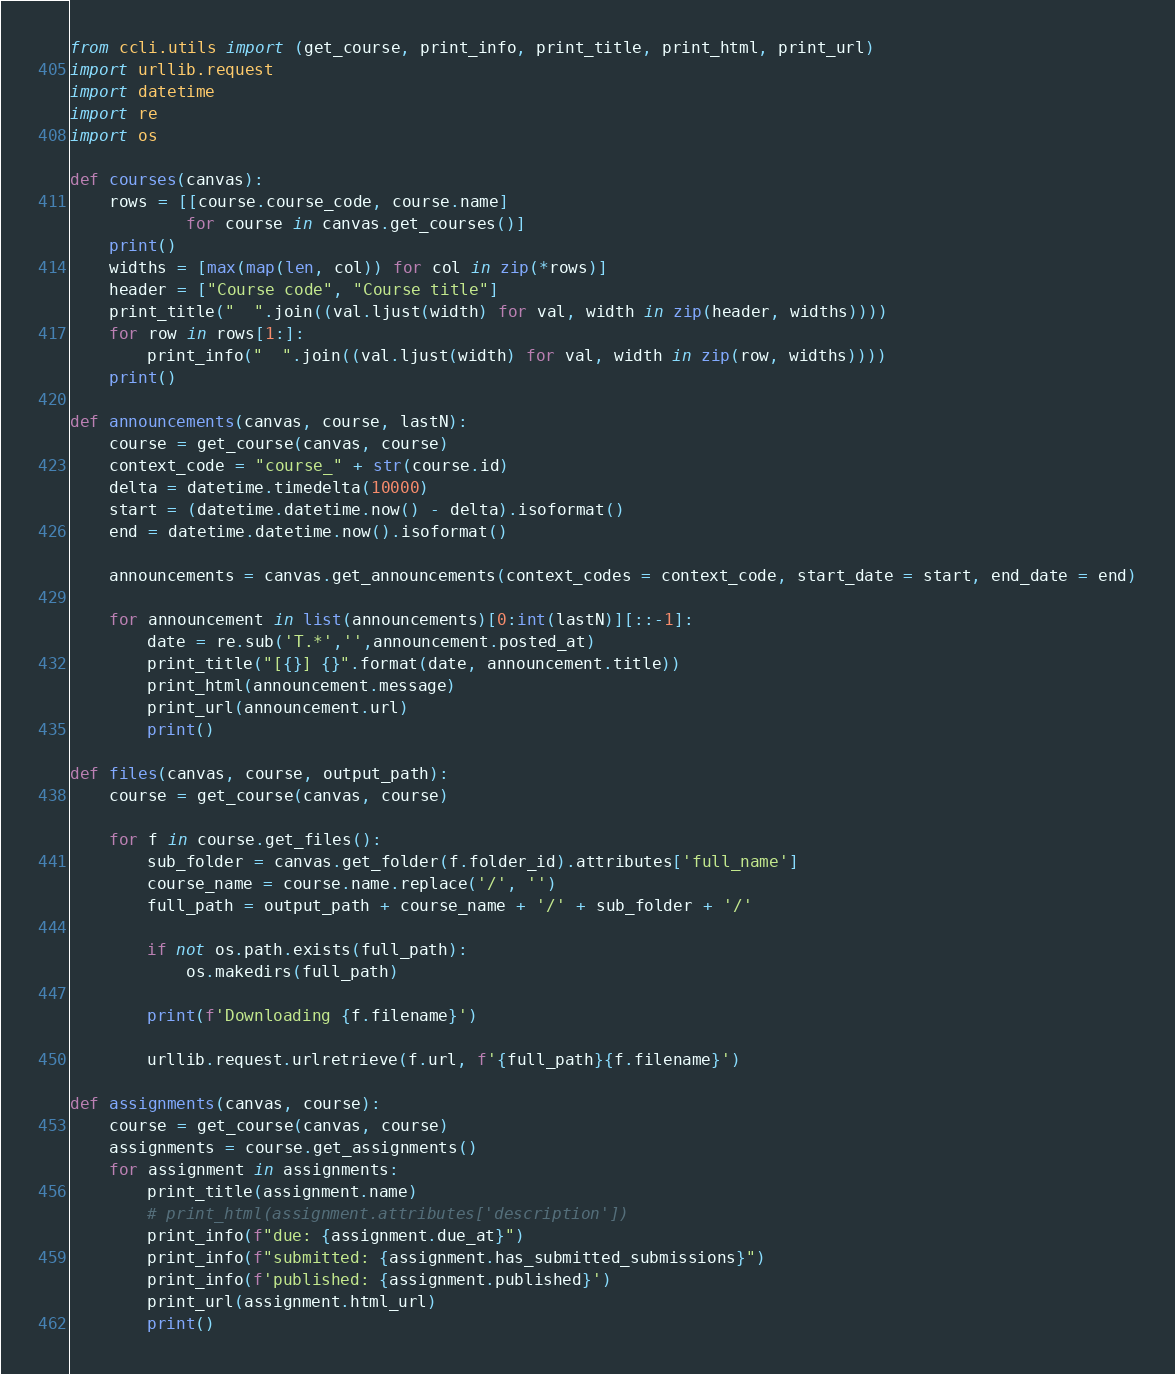Convert code to text. <code><loc_0><loc_0><loc_500><loc_500><_Python_>from ccli.utils import (get_course, print_info, print_title, print_html, print_url) 
import urllib.request
import datetime
import re
import os

def courses(canvas):
    rows = [[course.course_code, course.name]
            for course in canvas.get_courses()]
    print()
    widths = [max(map(len, col)) for col in zip(*rows)]
    header = ["Course code", "Course title"]
    print_title("  ".join((val.ljust(width) for val, width in zip(header, widths))))
    for row in rows[1:]:
        print_info("  ".join((val.ljust(width) for val, width in zip(row, widths))))
    print()

def announcements(canvas, course, lastN):
    course = get_course(canvas, course)
    context_code = "course_" + str(course.id)
    delta = datetime.timedelta(10000)
    start = (datetime.datetime.now() - delta).isoformat()
    end = datetime.datetime.now().isoformat()

    announcements = canvas.get_announcements(context_codes = context_code, start_date = start, end_date = end)

    for announcement in list(announcements)[0:int(lastN)][::-1]:
        date = re.sub('T.*','',announcement.posted_at)
        print_title("[{}] {}".format(date, announcement.title))
        print_html(announcement.message)
        print_url(announcement.url)
        print()

def files(canvas, course, output_path):
    course = get_course(canvas, course)

    for f in course.get_files():
        sub_folder = canvas.get_folder(f.folder_id).attributes['full_name']
        course_name = course.name.replace('/', '')
        full_path = output_path + course_name + '/' + sub_folder + '/'

        if not os.path.exists(full_path):
            os.makedirs(full_path)

        print(f'Downloading {f.filename}')

        urllib.request.urlretrieve(f.url, f'{full_path}{f.filename}')

def assignments(canvas, course):
    course = get_course(canvas, course)
    assignments = course.get_assignments()
    for assignment in assignments:
        print_title(assignment.name)
        # print_html(assignment.attributes['description'])
        print_info(f"due: {assignment.due_at}")
        print_info(f"submitted: {assignment.has_submitted_submissions}")
        print_info(f'published: {assignment.published}')
        print_url(assignment.html_url)
        print()</code> 